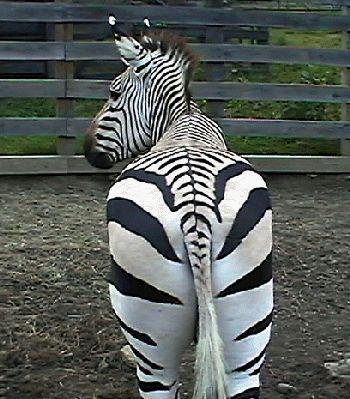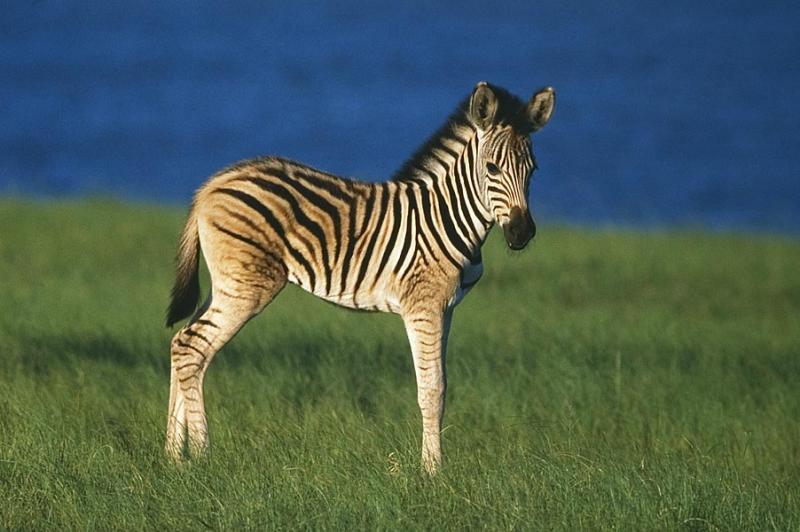The first image is the image on the left, the second image is the image on the right. Considering the images on both sides, is "An image shows a zebra with its body facing left and its snout over the back of a smaller zebra." valid? Answer yes or no. No. The first image is the image on the left, the second image is the image on the right. Evaluate the accuracy of this statement regarding the images: "There are at least two very young zebra here.". Is it true? Answer yes or no. No. 